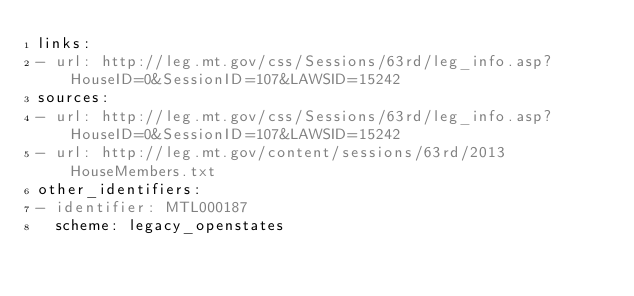Convert code to text. <code><loc_0><loc_0><loc_500><loc_500><_YAML_>links:
- url: http://leg.mt.gov/css/Sessions/63rd/leg_info.asp?HouseID=0&SessionID=107&LAWSID=15242
sources:
- url: http://leg.mt.gov/css/Sessions/63rd/leg_info.asp?HouseID=0&SessionID=107&LAWSID=15242
- url: http://leg.mt.gov/content/sessions/63rd/2013HouseMembers.txt
other_identifiers:
- identifier: MTL000187
  scheme: legacy_openstates
</code> 